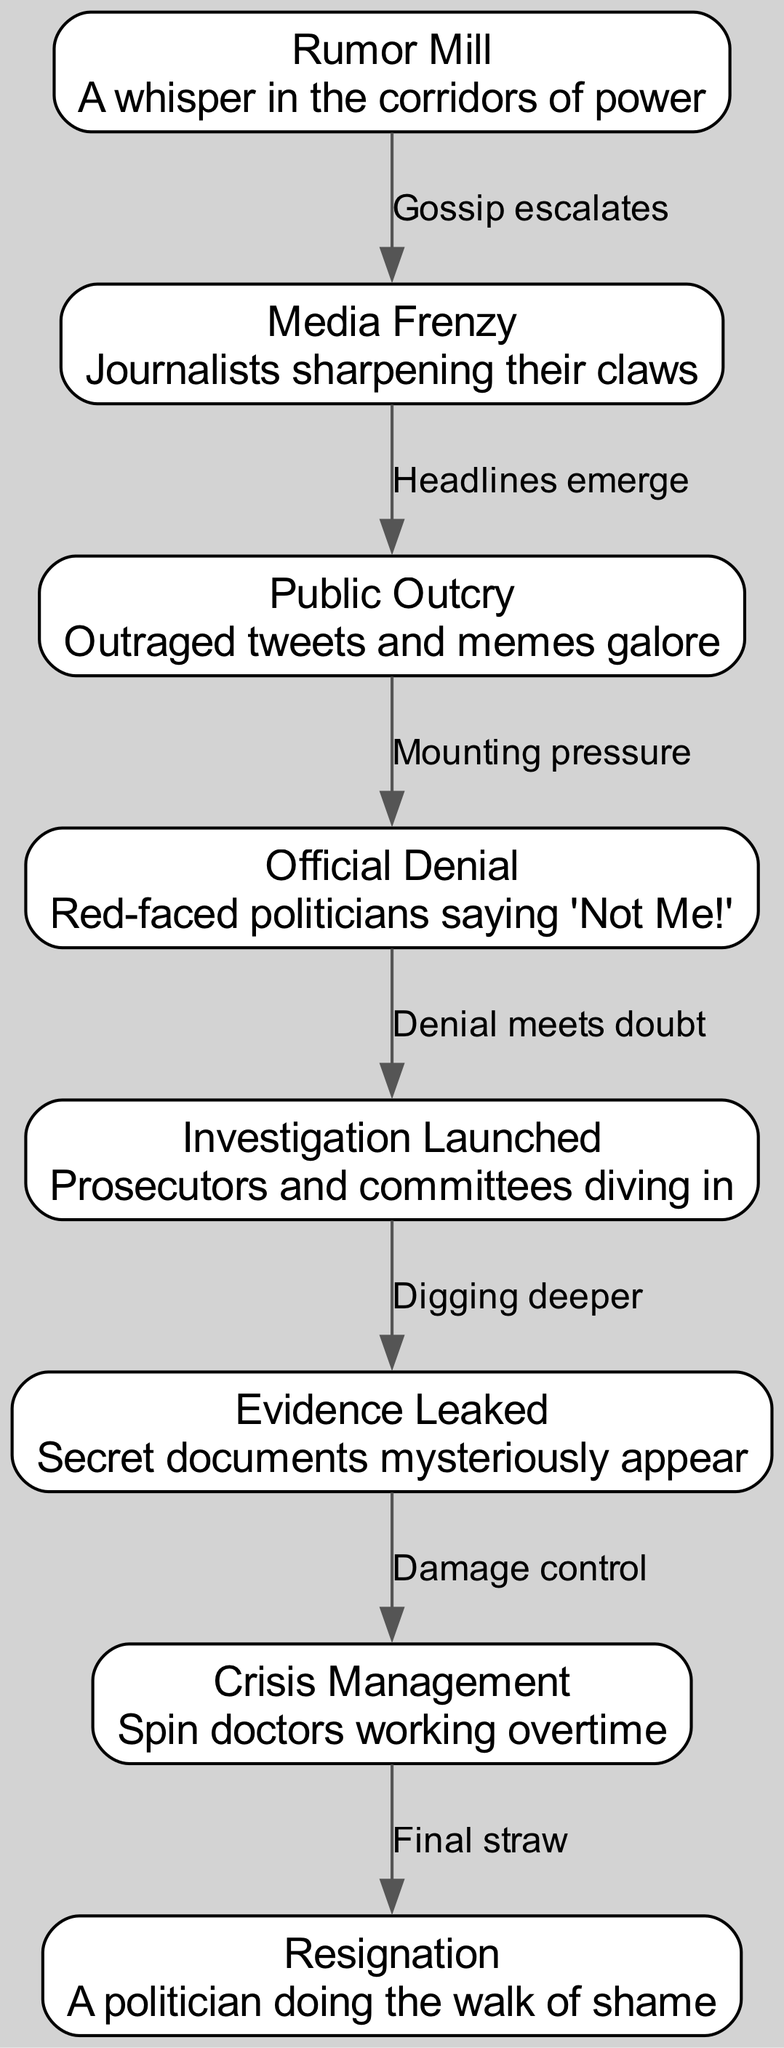What is the first stage in the lifecycle of a political scandal? The diagram starts with the first node labeled "Rumor Mill," which represents the initial stage of a political scandal. This is where the whispers begin.
Answer: Rumor Mill How many nodes are present in the diagram? The diagram contains a total of eight nodes, each representing a different stage in the political scandal lifecycle.
Answer: Eight What happens when the media frenzy begins? According to the diagram, when the media frenzy begins at the "Media Frenzy" stage, the gossip from the previous stage escalates into intense coverage, represented by the edge labeled "Gossip escalates."
Answer: Gossip escalates What is the last stage depicted in the lifecycle? The diagram concludes with the last node labeled "Resignation," indicating the final outcome of the political scandal lifecycle.
Answer: Resignation What does the "Crisis Management" stage involve? In the "Crisis Management" stage, the diagram indicates that "Spin doctors working overtime" represents the efforts being made to control the damage caused by the scandal.
Answer: Spin doctors working overtime Which two stages are connected by the edge labeled "Denial meets doubt"? The edge labeled "Denial meets doubt" connects the "Official Denial" stage to the "Investigation Launched" stage, showing how denial leads to further scrutiny as investigations are opened.
Answer: Official Denial and Investigation Launched What kind of documents appear during the "Evidence Leaked" stage? The description under the "Evidence Leaked" stage notes that "Secret documents mysteriously appear," highlighting the sudden unearthing of incriminating evidence.
Answer: Secret documents Which stage is characterized by "Outraged tweets and memes galore"? This phrase describes the "Public Outcry" stage, which features the public's energetic response to the unfolding scandal, especially on social media platforms.
Answer: Public Outcry 